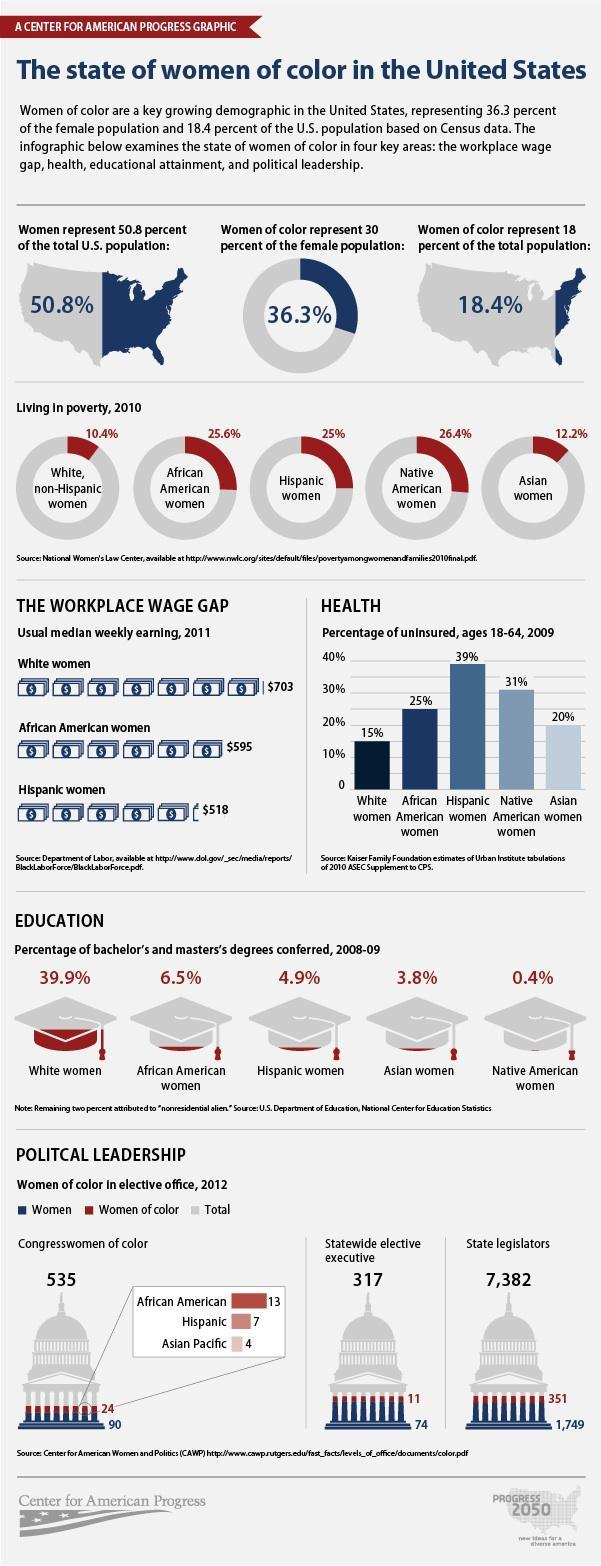What is the percentage of African American women living in poverty?
Answer the question with a short phrase. 25.6% What was the count of men state legislators in 2012? 5,282 Which ethnic group has a second lowest percentage of uninsured women? Asian women What is the percentage of native American women who have conferred education degrees? 0.4% What was the total number of  Congresswomen in 2012 ? 114 